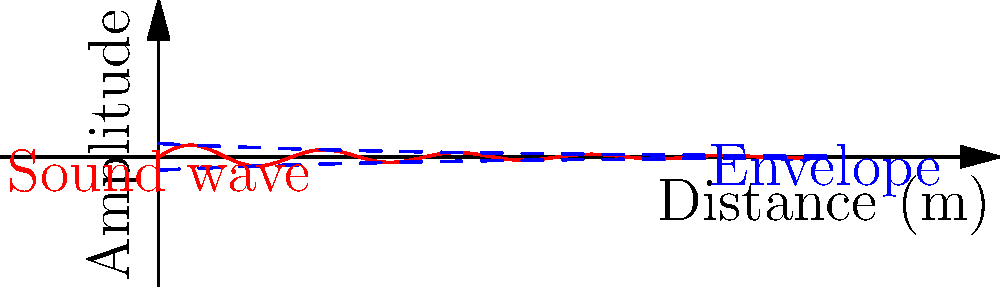In an underground tunnel, a sound wave propagates as shown in the graph. The wave's amplitude decreases exponentially with distance due to attenuation. If the initial amplitude is 100 dB and the attenuation coefficient is 0.05 m⁻¹, at what distance from the source will the sound level drop to 85 dB? To solve this problem, we'll follow these steps:

1) The sound level attenuation in decibels is given by the formula:
   $$ L = L_0 - 8.686 \alpha x $$
   where $L$ is the final sound level, $L_0$ is the initial sound level, $\alpha$ is the attenuation coefficient, and $x$ is the distance.

2) We're given:
   $L_0 = 100$ dB
   $L = 85$ dB
   $\alpha = 0.05$ m⁻¹

3) Substituting these values into the equation:
   $$ 85 = 100 - 8.686 \cdot 0.05 \cdot x $$

4) Simplifying:
   $$ -15 = -0.4343x $$

5) Solving for $x$:
   $$ x = \frac{15}{0.4343} \approx 34.54 \text{ m} $$

Therefore, the sound level will drop to 85 dB at approximately 34.54 meters from the source.
Answer: 34.54 m 